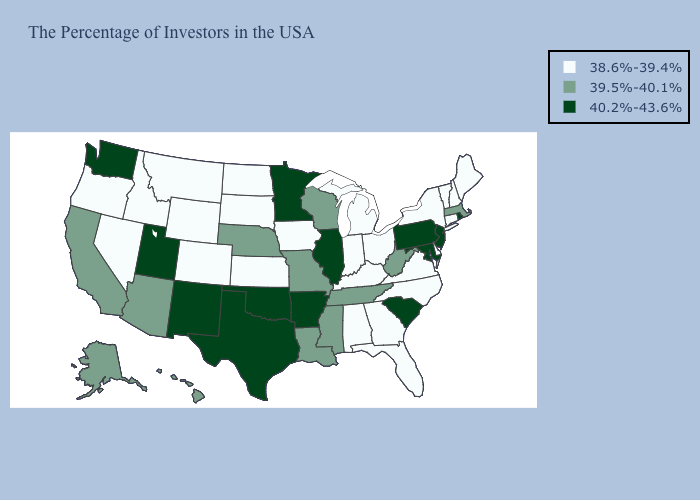Does the first symbol in the legend represent the smallest category?
Concise answer only. Yes. What is the value of New Jersey?
Be succinct. 40.2%-43.6%. Name the states that have a value in the range 39.5%-40.1%?
Concise answer only. Massachusetts, West Virginia, Tennessee, Wisconsin, Mississippi, Louisiana, Missouri, Nebraska, Arizona, California, Alaska, Hawaii. Name the states that have a value in the range 40.2%-43.6%?
Concise answer only. Rhode Island, New Jersey, Maryland, Pennsylvania, South Carolina, Illinois, Arkansas, Minnesota, Oklahoma, Texas, New Mexico, Utah, Washington. Does the first symbol in the legend represent the smallest category?
Short answer required. Yes. What is the lowest value in the USA?
Answer briefly. 38.6%-39.4%. What is the value of Nevada?
Short answer required. 38.6%-39.4%. Name the states that have a value in the range 38.6%-39.4%?
Write a very short answer. Maine, New Hampshire, Vermont, Connecticut, New York, Delaware, Virginia, North Carolina, Ohio, Florida, Georgia, Michigan, Kentucky, Indiana, Alabama, Iowa, Kansas, South Dakota, North Dakota, Wyoming, Colorado, Montana, Idaho, Nevada, Oregon. Among the states that border Alabama , which have the lowest value?
Keep it brief. Florida, Georgia. What is the highest value in the USA?
Be succinct. 40.2%-43.6%. What is the value of North Carolina?
Give a very brief answer. 38.6%-39.4%. Which states have the highest value in the USA?
Answer briefly. Rhode Island, New Jersey, Maryland, Pennsylvania, South Carolina, Illinois, Arkansas, Minnesota, Oklahoma, Texas, New Mexico, Utah, Washington. What is the highest value in the MidWest ?
Give a very brief answer. 40.2%-43.6%. What is the value of Alabama?
Quick response, please. 38.6%-39.4%. What is the value of North Dakota?
Keep it brief. 38.6%-39.4%. 